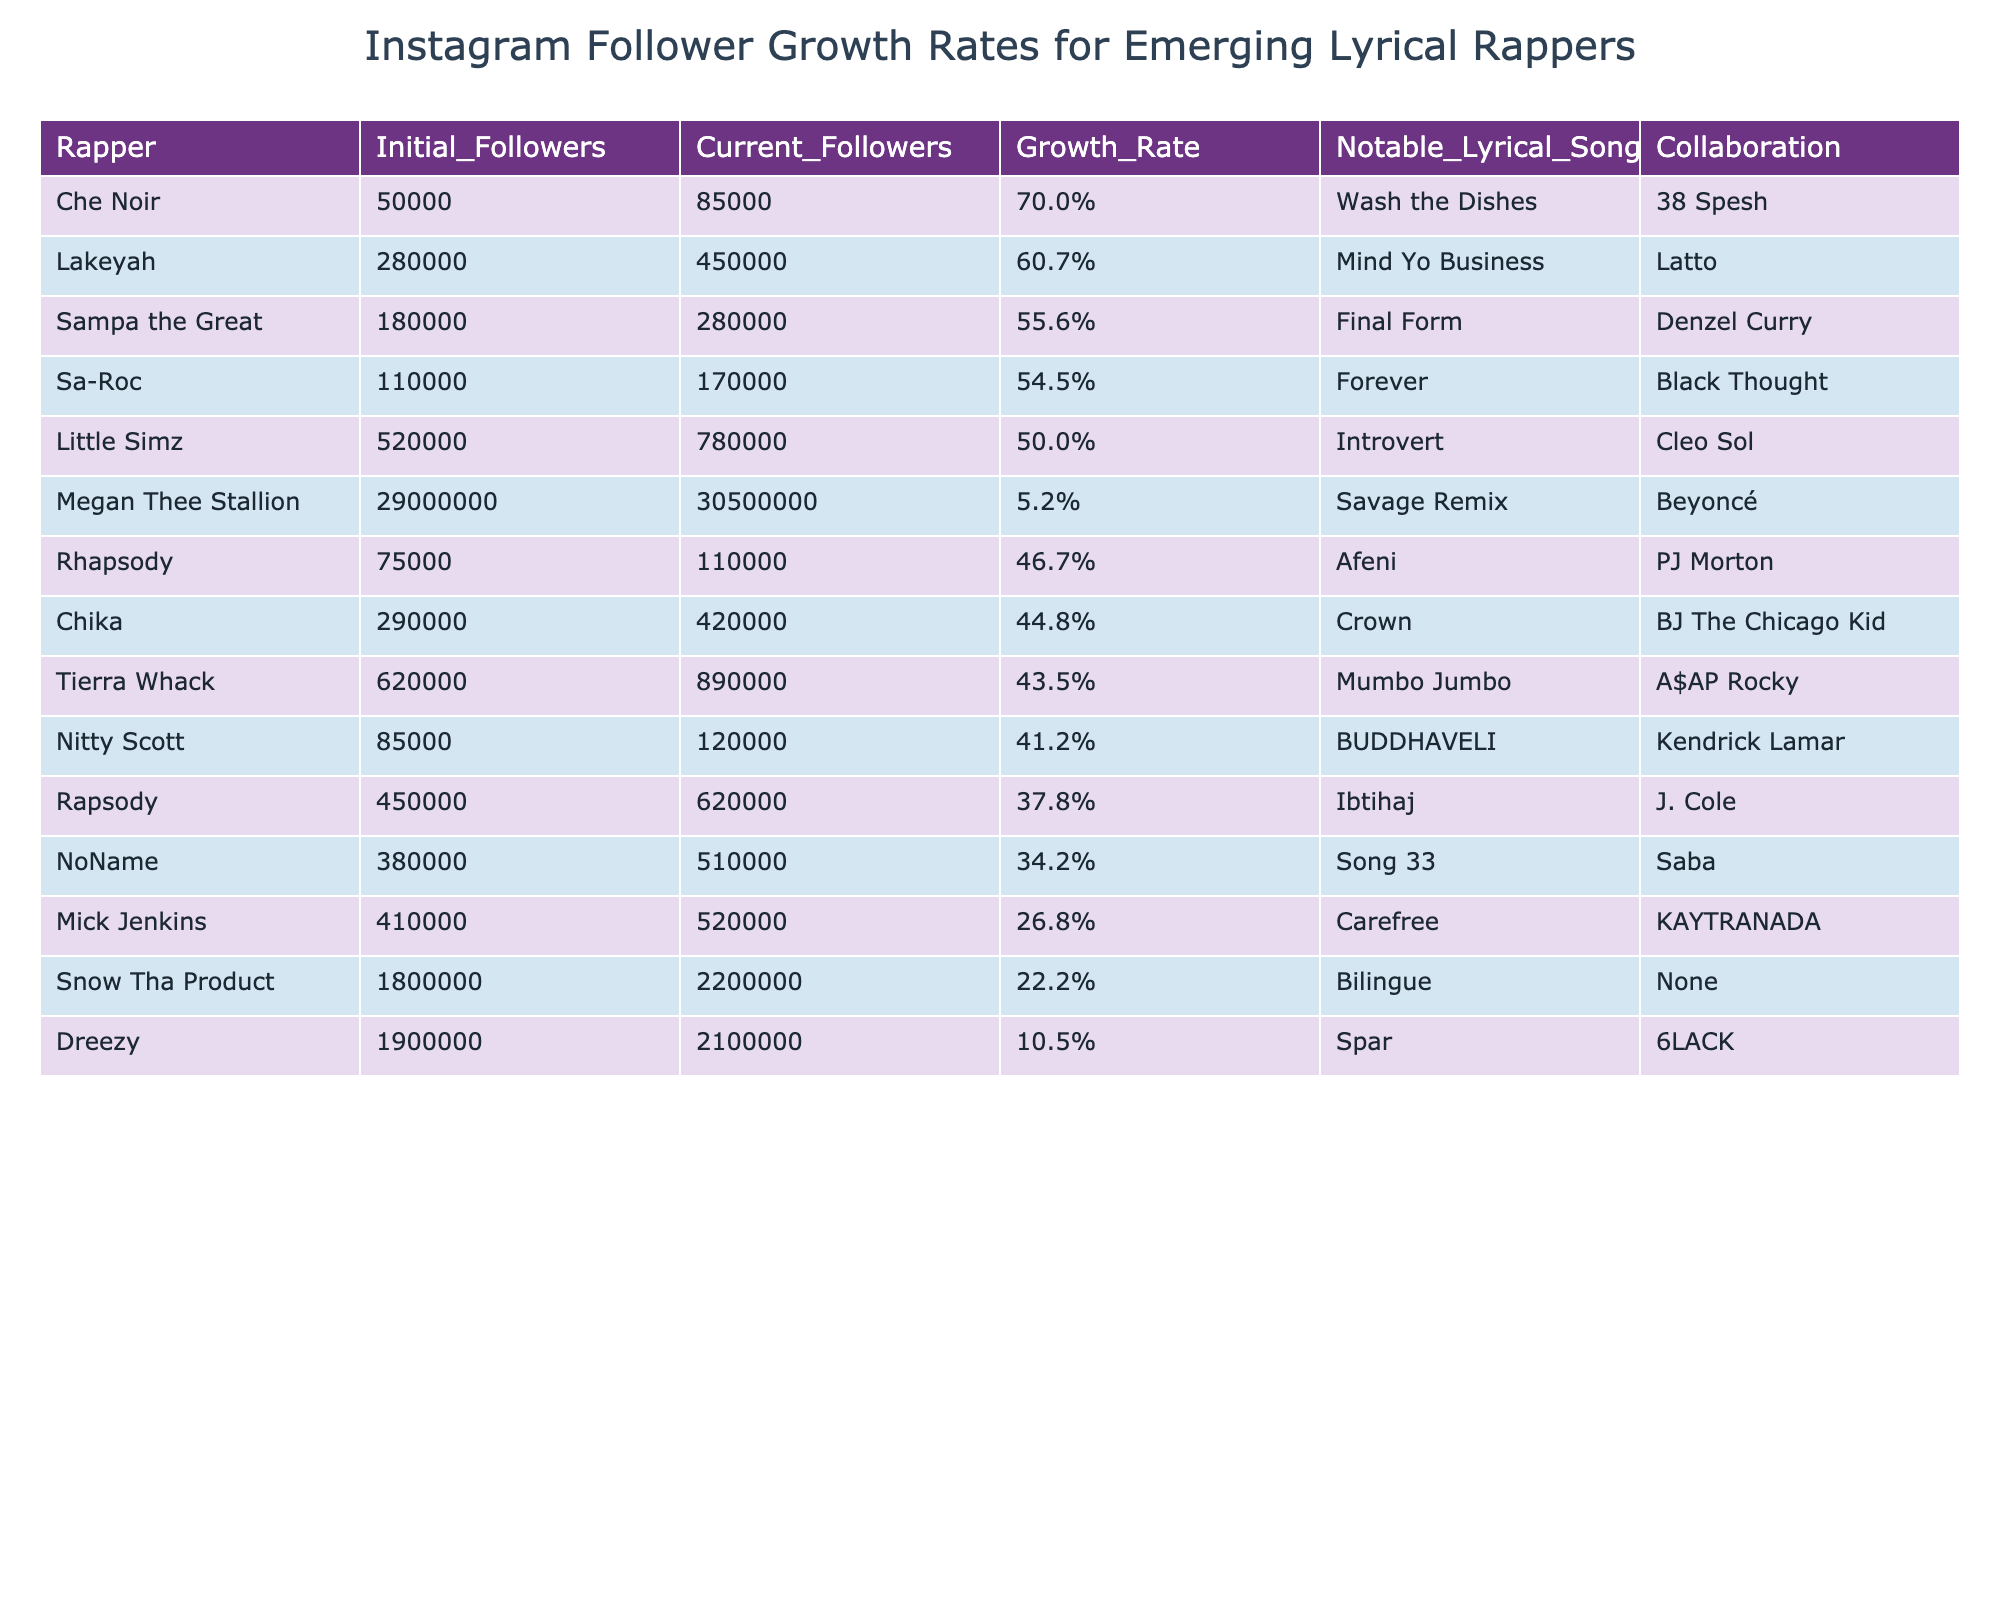What is the growth rate of Little Simz? Little Simz's growth rate is listed under the "Growth_Rate" column in the table, and it shows a growth rate of 50.0%.
Answer: 50.0% Which rapper experienced the highest follower growth rate? To find this, I look at the "Growth_Rate" column and see that Che Noir has the highest growth rate at 70.0%.
Answer: Che Noir How many current followers does Rapsody have? Rapsody's current followers are found in the "Current_Followers" column, which shows a total of 620,000 followers.
Answer: 620,000 Did Sa-Roc have a higher growth rate than Nitty Scott? Comparing the growth rates, Sa-Roc's is at 54.5%, while Nitty Scott's is at 41.2%. Since 54.5% is greater than 41.2%, the answer is yes.
Answer: Yes What is the average growth rate of the rappers listed in the table? To find the average, I add up all the growth rates (37.8% + 34.2% + 50.0% + 43.5% + 55.6% + 44.8% + 54.5% + 70.0% + 60.7% + 5.2% + 22.2% + 41.2% + 46.7% + 26.8% + 10.5% = 605.7%) and then divide by the number of rappers (15), resulting in an average growth rate of 40.38%.
Answer: 40.38% Which rapper had the least increase in percentage of followers? Looking at the "Growth_Rate" column, Megan Thee Stallion has the lowest growth rate at 5.2%.
Answer: Megan Thee Stallion What is the total follower count for all rappers in the table now? I sum the "Current_Followers" for all rappers: 620,000 + 510,000 + 780,000 + 890,000 + 280,000 + 420,000 + 170,000 + 85,000 + 450,000 + 30,500,000 + 2,200,000 + 120,000 + 110,000 + 520,000 + 2,100,000 = 38,817,000 followers.
Answer: 38,817,000 Is Che Noir's notable lyrical song "Wash the Dishes"? Looking at the "Notable_Lyrical_Song" column for Che Noir confirms that her song is indeed "Wash the Dishes."
Answer: Yes What percentage of the rappers listed have a current follower count greater than 500,000? Counting the rappers with more than 500,000 current followers (Little Simz, Tierra Whack, Megan Thee Stallion, Snow Tha Product, Dreezy), I find there are 5 out of 15 rappers, which gives a percentage of (5/15) * 100 = 33.33%.
Answer: 33.33% How many rappers had a growth rate greater than 50%? I check the "Growth_Rate" column for values above 50% and find that Che Noir, Lakeyah, Sampa the Great, and Sa-Roc all meet this criterion, totaling 4 rappers.
Answer: 4 If we consider only the top three growth rates, what is the total number of current followers they have? The top three growth rates are Che Noir (85,000), Lakeyah (450,000), and Sampa the Great (280,000). Adding these current followers yields: 85,000 + 450,000 + 280,000 = 815,000 current followers.
Answer: 815,000 